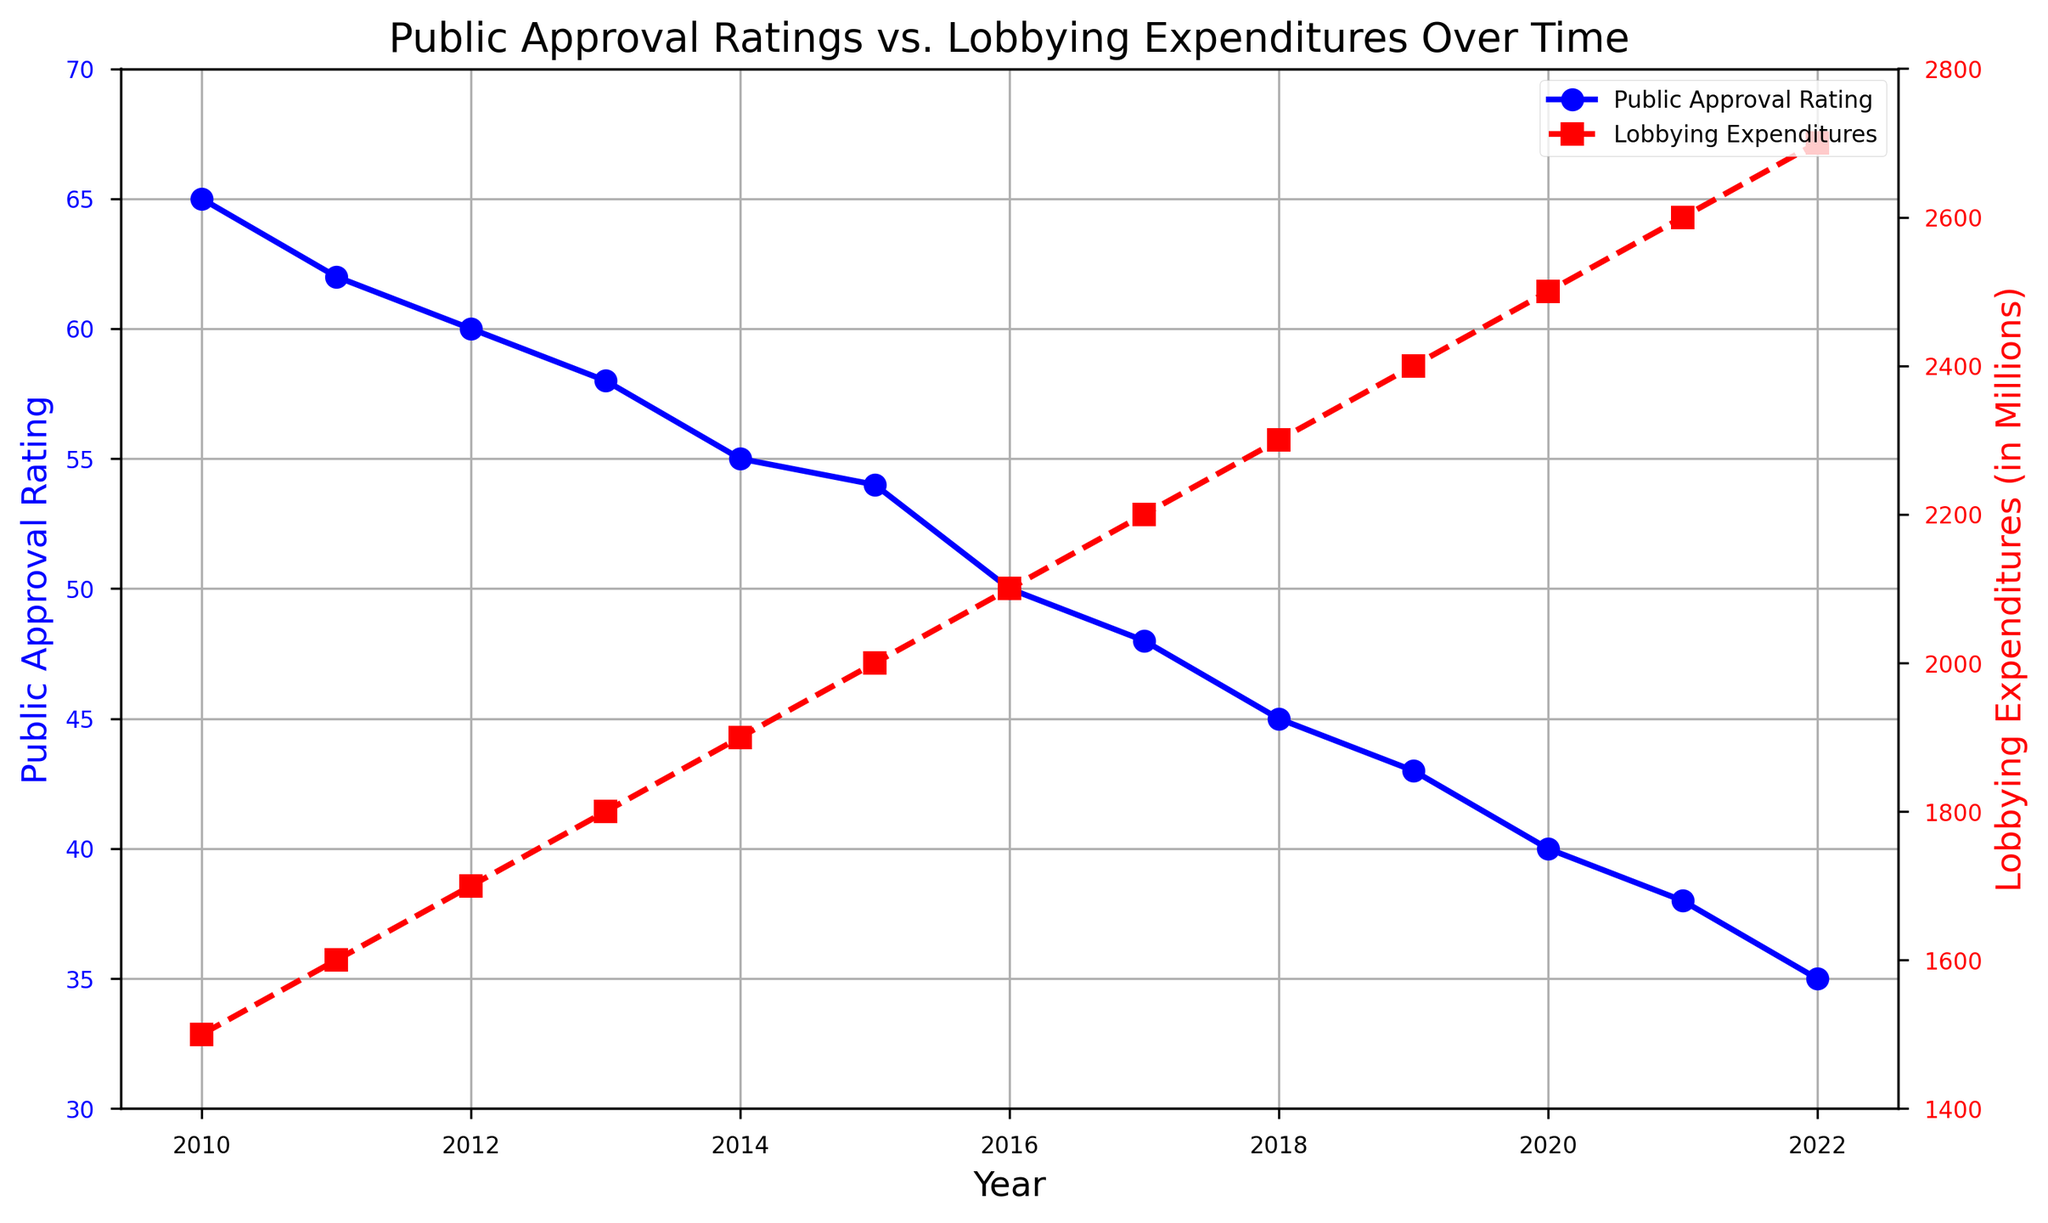What is the general trend of public approval ratings from 2010 to 2022? The public approval ratings generally show a declining trend from 65 in 2010 to 35 in 2022. To determine this, observe the blue line with markers on the left y-axis, which shows a decrease each year.
Answer: Declining How does lobbying expenditure change over the years depicted in the figure? Lobbying expenditures generally show an increasing trend from 1500 million in 2010 to 2700 million in 2022. This can be seen from the red dashed line with square markers on the right y-axis, which steadily rises each year.
Answer: Increasing What can you infer about the correlation between public approval ratings and lobbying expenditures over time? There appears to be a negative correlation between public approval ratings and lobbying expenditures. As lobbying expenditures increase (red line), public approval ratings decrease (blue line). This trend can be inferred by observing the simultaneous rise and fall of the respective lines over time.
Answer: Negative correlation Which year had the highest public approval rating and what was the corresponding lobbying expenditure for that year? The highest public approval rating was in 2010, with a rating of 65. The corresponding lobbying expenditure for that year was 1500 million. This can be identified by looking at the peak point of the blue line and matching it with the red line for the same year.
Answer: 2010, 1500 million In which year did the public approval rating drop below 50 for the first time? The public approval rating dropped below 50 for the first time in 2016, when it reached 50. This can be determined by tracing the blue line to the point where it first dips below 50.
Answer: 2016 What is the average public approval rating over the years 2010 to 2022? To calculate the average, sum all the public approval ratings from 2010 to 2022: 65 + 62 + 60 + 58 + 55 + 54 + 50 + 48 + 45 + 43 + 40 + 38 + 35 = 653. There are 13 years, so the average is 653 / 13 ≈ 50.23.
Answer: 50.23 By how much did the lobbying expenditures increase from 2010 to 2022? Subtract the lobbying expenditures in 2010 from those in 2022: 2700 million - 1500 million = 1200 million.
Answer: 1200 million What was the percentage decrease in public approval rating from 2010 to 2022? First, find the difference in public approval ratings between 2010 and 2022: 65 - 35 = 30. The percentage decrease is (30 / 65) * 100 ≈ 46.15%.
Answer: 46.15% Compare the public approval rating and lobbying expenditures in 2015 and 2020. Which year had a higher public approval rating and which had higher lobbying expenditures? In 2015, the public approval rating was 54 and lobbying expenditures were 2000 million. In 2020, the public approval rating was 40 and lobbying expenditures were 2500 million. Therefore, 2015 had a higher approval rating, and 2020 had higher lobbying expenditures.
Answer: 2015, 2020 What are the visual indicators used to differentiate between public approval ratings and lobbying expenditures in the figure? Different visual attributes such as line styles and colors are used. Public approval ratings are shown by a solid blue line with circular markers, and lobbying expenditures are depicted by a dashed red line with square markers.
Answer: Line styles and colors 